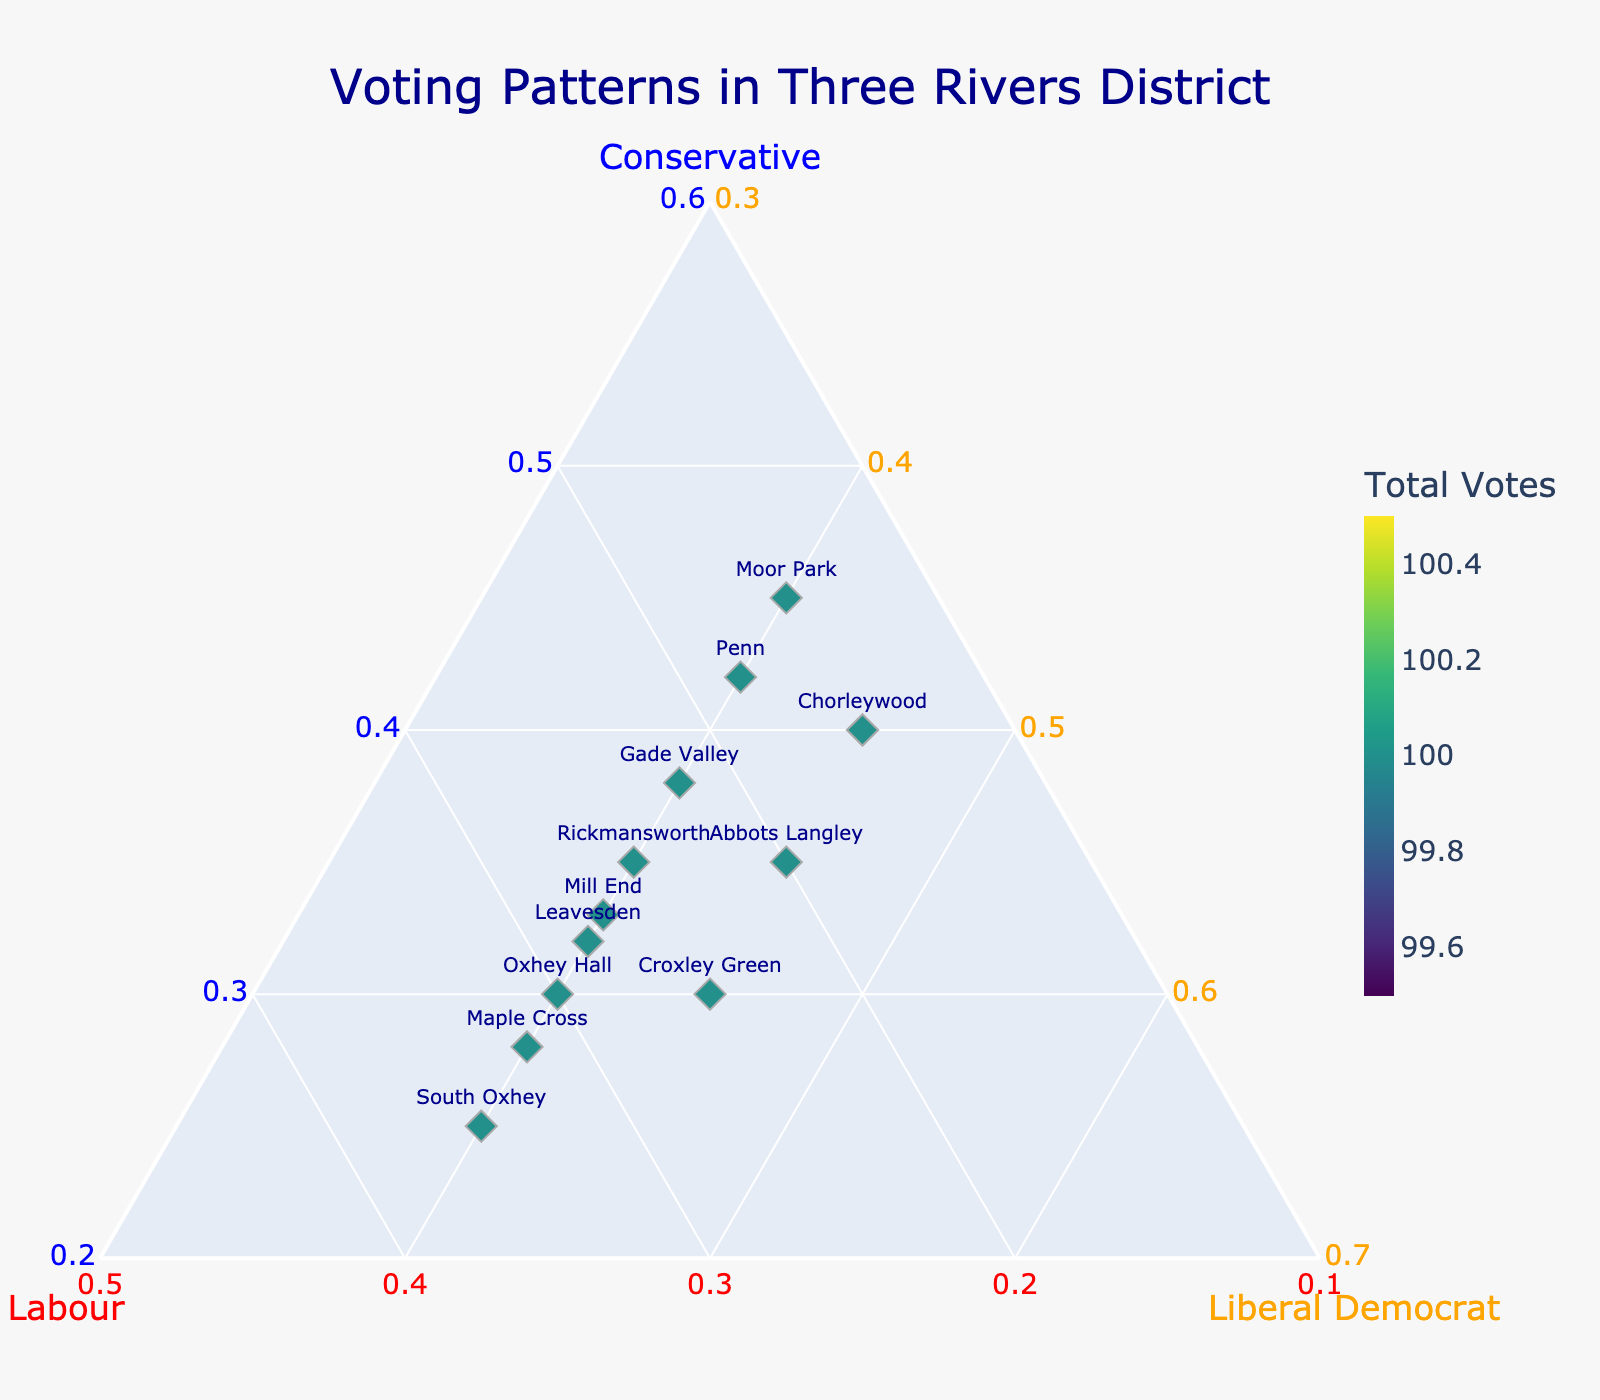How many wards are represented in the figure? Count the number of unique markers, each representing a ward, in the figure.
Answer: 12 What are the minimum and maximum values represented on the 'Labour' axis? Check the 'baxis' in the ternary plot, which has 'Labour' as the axis title. The values range from 0.1 to 1, but according to our boundary conditions, the minimum is adjusted to 0.1.
Answer: 0.1 and 0.3 Which ward has the highest percentage of votes for the Conservative party? Locate the marker closest to the 'Conservative' vertex of the ternary plot. This corresponds to the highest percentage of Conservative votes. The ward name is labeled.
Answer: Moor Park Compare the voting patterns between 'South Oxhey' and 'Moor Park'. Which ward has a higher proportion of votes for the Labour party? Check positions of the markers for 'South Oxhey' and 'Moor Park'. The 'y'-coordinate (b-axis) closer to the Labour vertex indicates a higher proportion.
Answer: South Oxhey For wards where the Liberal Democrat party received exactly 40% of votes, what is the range of Conservative vote percentages? First, filter the markers where the 'Liberal Democrat' axis value is exactly 0.40. Then, check the 'Conservative' percentages of those markers.
Answer: 25% to 45% What is the composition of votes in 'Croxley Green'? Locate the marker labeled 'Croxley Green' and read the values from the plot. The proportional values for Conservative, Labour, and Liberal Democrat are listed.
Answer: 30%, 25%, 45% Identify all wards with equal percentages of votes for Labour and Conservative parties. Look for markers where the a-axis and b-axis values are equal. These labels correspond to wards with equal vote percentages.
Answer: Oxhey Hall Among the wards where Labour received more votes than the Conservative party, which one has the least percentage of Labour votes? Filter markers where the b-axis value (Labour) is greater than the a-axis value (Conservative). Among these, find the minimum b-axis value.
Answer: Leavesden What does the figure's title say? Titles are usually located at the top-center of the figure. Identify and read the title text.
Answer: Voting Patterns in Three Rivers District 